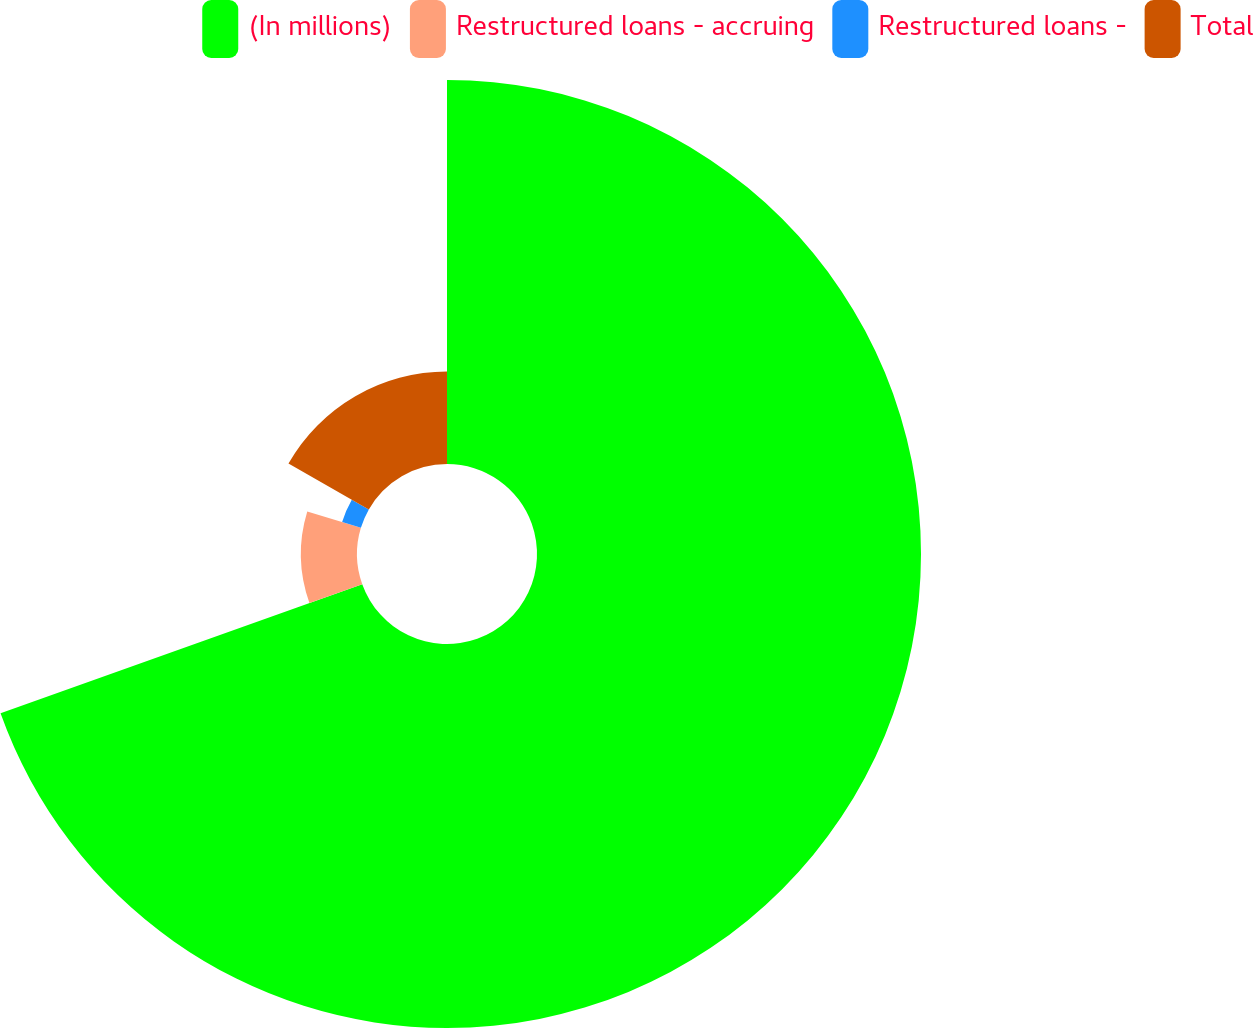Convert chart. <chart><loc_0><loc_0><loc_500><loc_500><pie_chart><fcel>(In millions)<fcel>Restructured loans - accruing<fcel>Restructured loans -<fcel>Total<nl><fcel>69.54%<fcel>10.15%<fcel>3.55%<fcel>16.75%<nl></chart> 